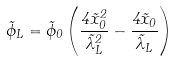Convert formula to latex. <formula><loc_0><loc_0><loc_500><loc_500>\tilde { \phi } _ { L } = \tilde { \phi } _ { 0 } \left ( \frac { 4 { \tilde { x } _ { 0 } } ^ { 2 } } { { { \tilde { \lambda } _ { L } } ^ { 2 } } } - \frac { 4 \tilde { x } _ { 0 } } { \tilde { \lambda } _ { L } } \right )</formula> 